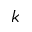Convert formula to latex. <formula><loc_0><loc_0><loc_500><loc_500>k</formula> 